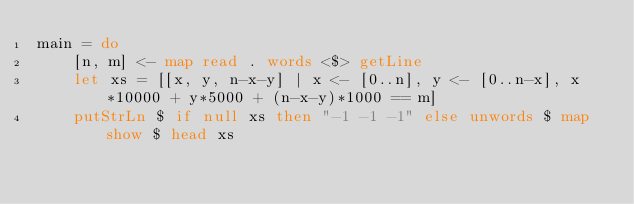Convert code to text. <code><loc_0><loc_0><loc_500><loc_500><_Haskell_>main = do
    [n, m] <- map read . words <$> getLine
    let xs = [[x, y, n-x-y] | x <- [0..n], y <- [0..n-x], x*10000 + y*5000 + (n-x-y)*1000 == m]
    putStrLn $ if null xs then "-1 -1 -1" else unwords $ map show $ head xs
</code> 